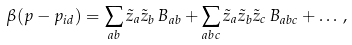<formula> <loc_0><loc_0><loc_500><loc_500>\beta ( p - p _ { i d } ) = \sum _ { a b } { \tilde { z } } _ { a } { \tilde { z } } _ { b } \, B _ { a b } + \sum _ { a b c } { \tilde { z } } _ { a } { \tilde { z } } _ { b } { \tilde { z } } _ { c } \, B _ { a b c } + \dots \, ,</formula> 